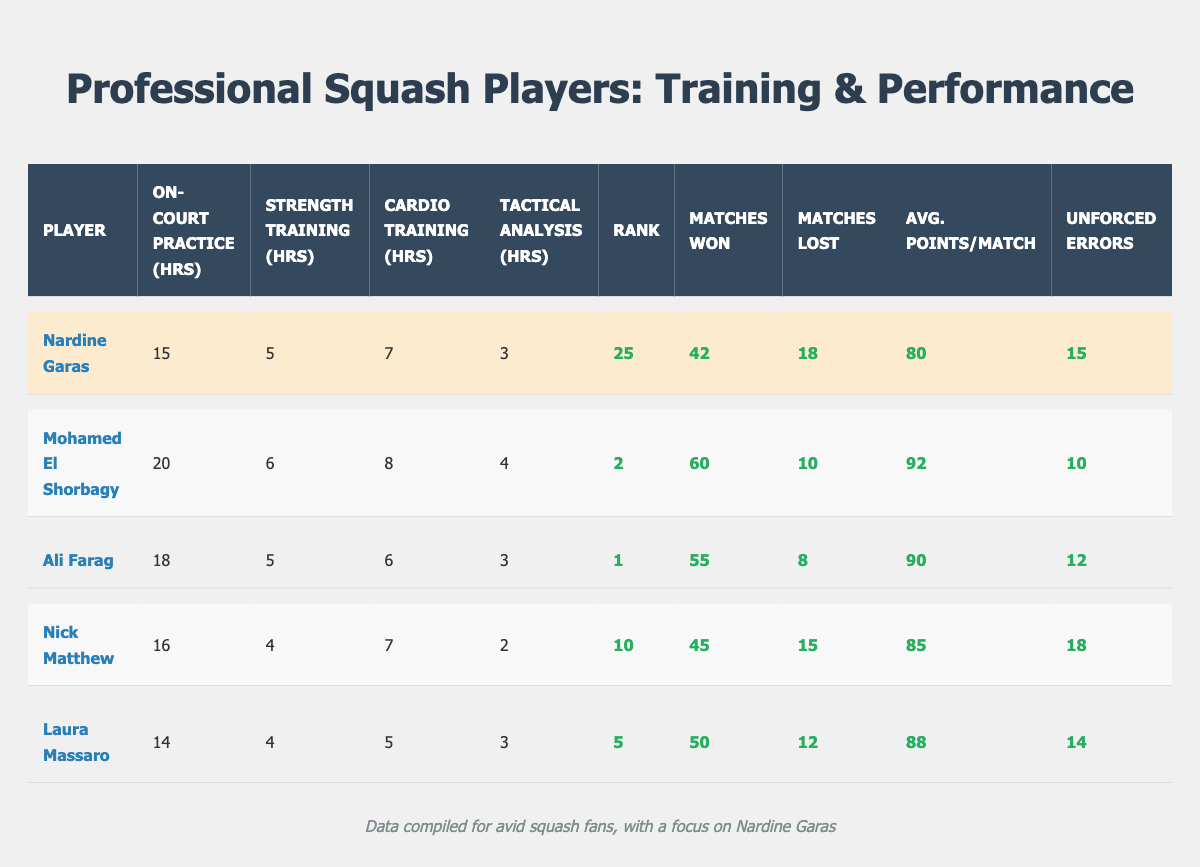What is the average number of on-court practice hours among the players? The players along with their on-court practice hours are: Nardine Garas (15), Mohamed El Shorbagy (20), Ali Farag (18), Nick Matthew (16), and Laura Massaro (14). Summing these gives 15 + 20 + 18 + 16 + 14 = 83. There are 5 players, so the average is 83/5 = 16.6.
Answer: 16.6 How many matches has Nardine Garas won? Nardine Garas has won 42 matches, as directly referenced in the table under "Matches Won".
Answer: 42 Which player has the highest average points per match? The players' average points per match are as follows: Nardine Garas (80), Mohamed El Shorbagy (92), Ali Farag (90), Nick Matthew (85), Laura Massaro (88). Comparing these, Mohamed El Shorbagy has the highest at 92.
Answer: Mohamed El Shorbagy True or False: Laura Massaro has more matches lost than Nardine Garas. Laura Massaro lost 12 matches while Nardine Garas lost 18. Since 12 is less than 18, the statement is false.
Answer: False What is the total number of matches won by all players? The total number of matches won is calculated by summing the matches won by each player: 42 (Nardine Garas) + 60 (Mohamed El Shorbagy) + 55 (Ali Farag) + 45 (Nick Matthew) + 50 (Laura Massaro) = 252.
Answer: 252 Which player has both a higher squash rank and fewer unforced errors than Nardine Garas? Nardine Garas has a squash rank of 25 and 15 unforced errors. Checking the others: Mohamed El Shorbagy (rank 2, unforced errors 10), Ali Farag (rank 1, unforced errors 12), Nick Matthew (rank 10, unforced errors 18), and Laura Massaro (rank 5, unforced errors 14)—both Mohamed El Shorbagy and Ali Farag meet these criteria.
Answer: Mohamed El Shorbagy and Ali Farag What is the difference in cardio training hours between the player with the highest rank and Nardine Garas? The player with the highest rank is Ali Farag (rank 1) with 6 cardio training hours, while Nardine Garas has 7 hours. The difference is 7 - 6 = 1 hour.
Answer: 1 hour Who has the least amount of off-court strength training hours? Looking at the off-court strength training hours: Nardine Garas (5), Mohamed El Shorbagy (6), Ali Farag (5), Nick Matthew (4), and Laura Massaro (4). Nick Matthew and Laura Massaro both have the least at 4 hours.
Answer: Nick Matthew and Laura Massaro What is the ratio of matches won to matches lost for Nardine Garas? Nardine Garas won 42 matches and lost 18. The ratio is 42:18, which simplifies to 7:3 when both numbers are divided by 6.
Answer: 7:3 How many total hours does Nardine Garas spend on training each week? Nardine Garas's training hours are: 15 on-court + 5 strength + 7 cardio + 3 tactical analysis = 30 hours total.
Answer: 30 hours 